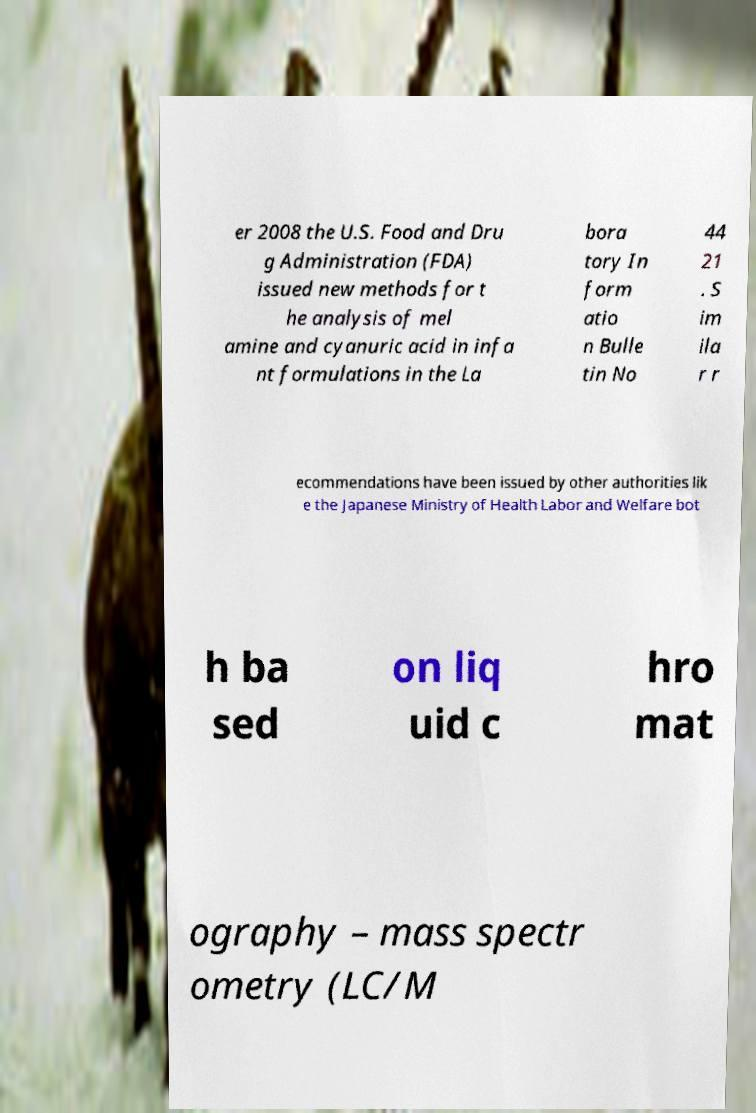Could you extract and type out the text from this image? er 2008 the U.S. Food and Dru g Administration (FDA) issued new methods for t he analysis of mel amine and cyanuric acid in infa nt formulations in the La bora tory In form atio n Bulle tin No 44 21 . S im ila r r ecommendations have been issued by other authorities lik e the Japanese Ministry of Health Labor and Welfare bot h ba sed on liq uid c hro mat ography – mass spectr ometry (LC/M 